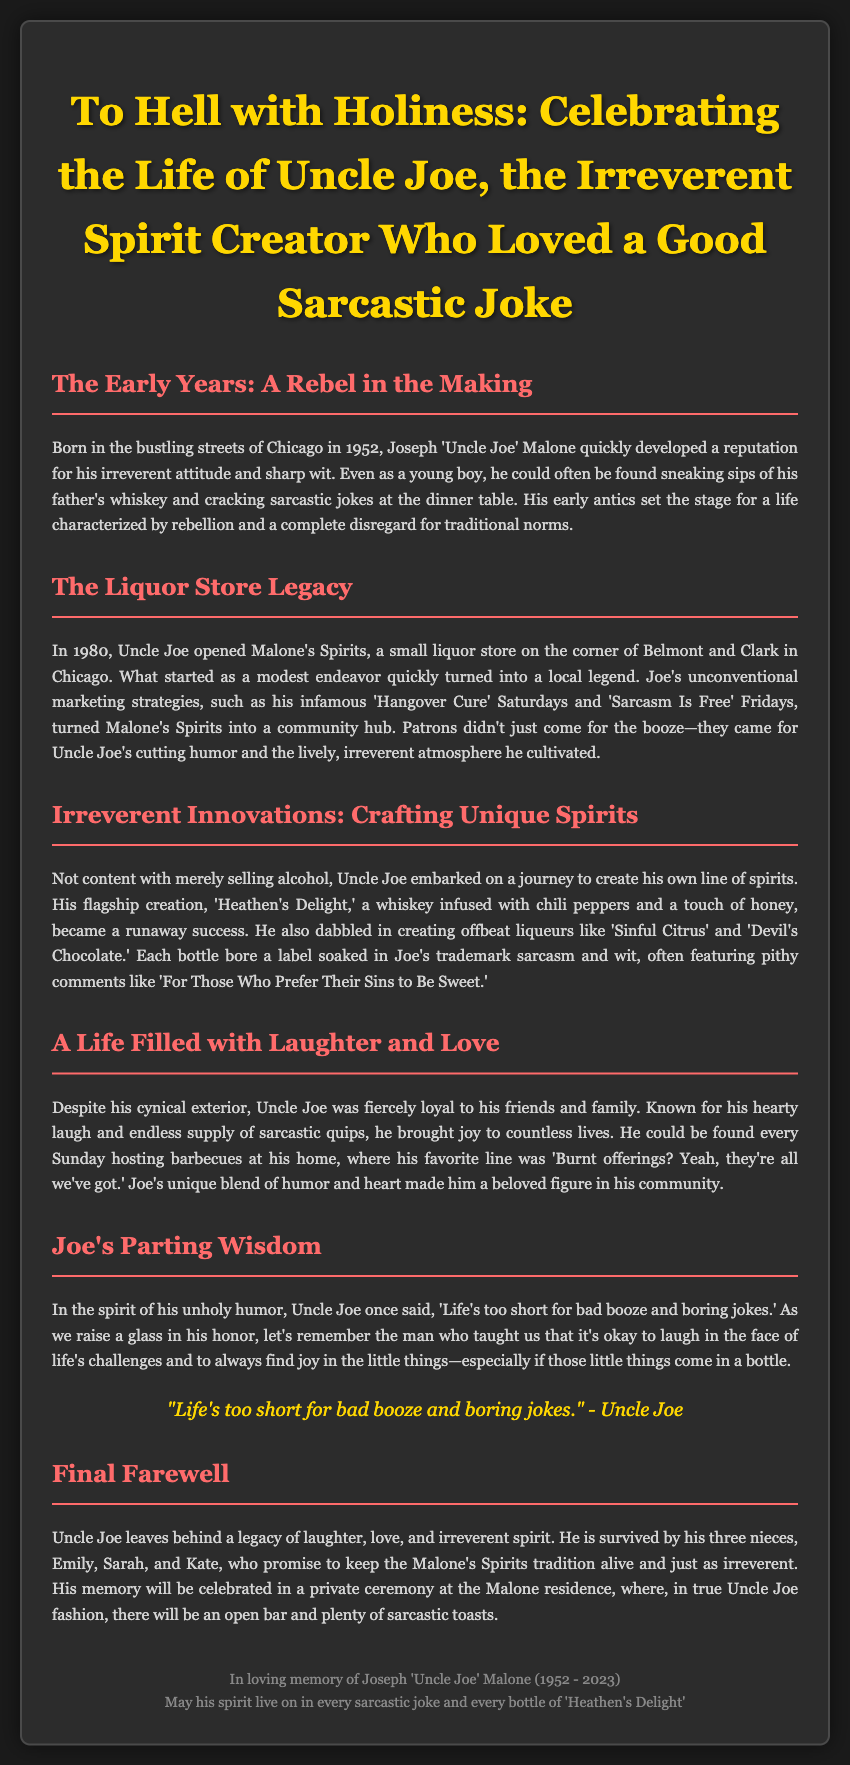What year was Uncle Joe born? Uncle Joe was born in 1952 according to the early years section of the obituary.
Answer: 1952 What was the name of Uncle Joe's liquor store? The liquor store that Uncle Joe opened is called Malone's Spirits.
Answer: Malone's Spirits What was Uncle Joe's flagship spirit? Uncle Joe's flagship creation was 'Heathen's Delight.'
Answer: Heathen's Delight How many nieces did Uncle Joe leave behind? Uncle Joe is survived by three nieces, as mentioned in the final farewell section.
Answer: three What humorous advice did Uncle Joe give about life? Uncle Joe's parting wisdom included the phrase 'Life's too short for bad booze and boring jokes.'
Answer: 'Life's too short for bad booze and boring jokes.' Why did patrons visit Malone's Spirits according to the document? Patrons came for both the liquor and Uncle Joe's cutting humor.
Answer: liquor and Uncle Joe's cutting humor What theme runs through Uncle Joe's spirit labels? The theme of Uncle Joe's spirit labels was sarcasm and wit, as described in the innovations section.
Answer: sarcasm and wit What culinary event did Uncle Joe host every Sunday? Uncle Joe hosted barbecues at his home every Sunday.
Answer: barbecues 